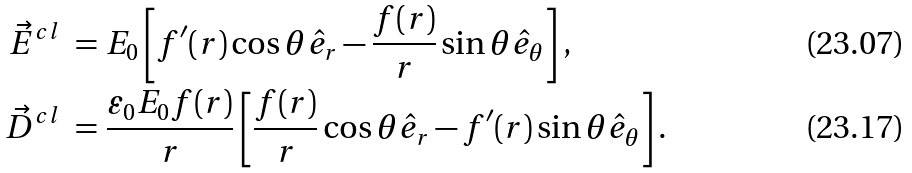Convert formula to latex. <formula><loc_0><loc_0><loc_500><loc_500>\vec { E } ^ { c l } \ = \ & E _ { 0 } \left [ f ^ { \prime } ( r ) \cos \theta \hat { e } _ { r } - \frac { f ( r ) } { r } \sin \theta \hat { e } _ { \theta } \right ] , \\ \vec { D } ^ { c l } \ = \ & \frac { \varepsilon _ { 0 } E _ { 0 } f ( r ) } { r } \left [ \frac { f ( r ) } { r } \cos \theta \hat { e } _ { r } - f ^ { \prime } ( r ) \sin \theta \hat { e } _ { \theta } \right ] .</formula> 